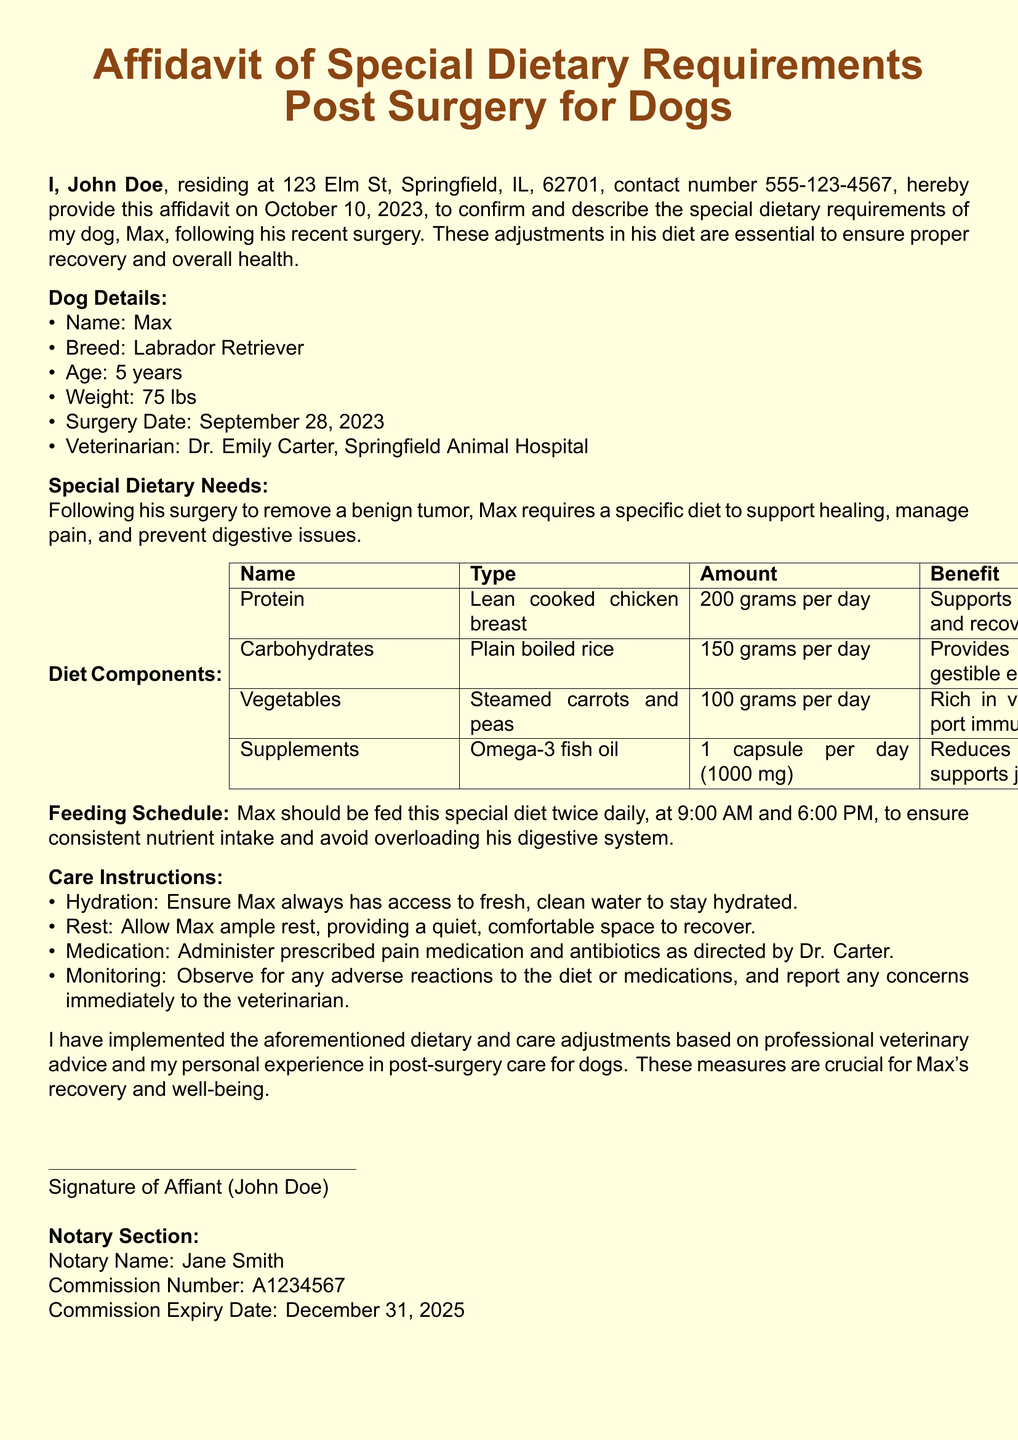What is the name of the dog? The name of the dog is explicitly mentioned in the document under dog details.
Answer: Max What is the breed of the dog? The breed of the dog is provided in the document's dog details section.
Answer: Labrador Retriever When was the surgery date? The surgery date is specified in the documents under the dog details section.
Answer: September 28, 2023 What is the daily amount of lean cooked chicken breast required? The daily amount of lean cooked chicken breast can be found in the diet components table.
Answer: 200 grams per day How often should Max be fed? The feeding schedule indicates how often Max should be fed.
Answer: Twice daily Who is the veterinarian? The veterinarian's name is listed in the dog details section of the document.
Answer: Dr. Emily Carter What supplement is included in Max's diet? The diet components table mentions the specific supplement included in Max's diet.
Answer: Omega-3 fish oil What is the benefit of feeding plain boiled rice? The benefit of plain boiled rice is stated in the diet components table.
Answer: Provides easily digestible energy What is the notary's commission expiry date? The notary's commission expiry date is mentioned in the notary section of the document.
Answer: December 31, 2025 